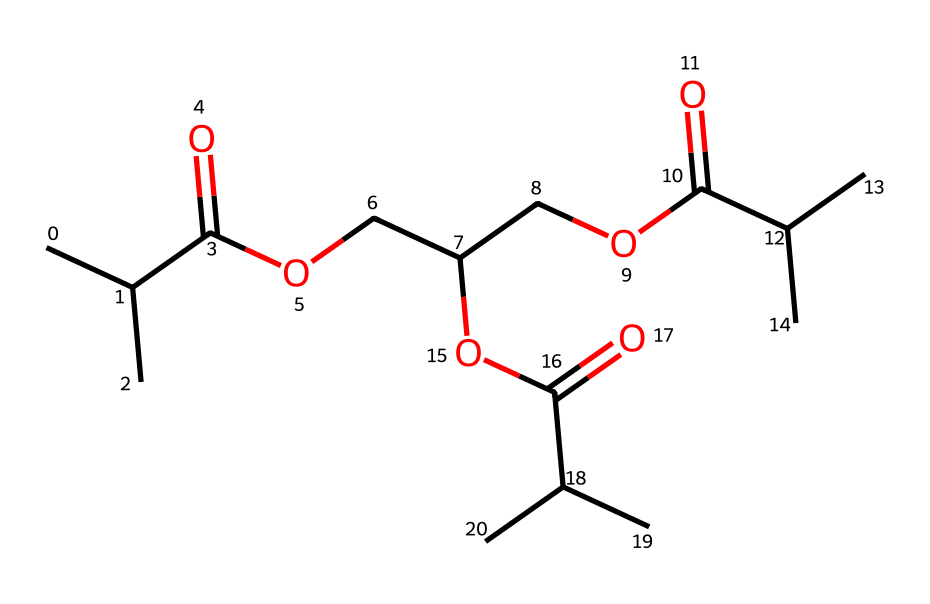What is the molecular formula of this chemical? To determine the molecular formula, we count the number of each type of atom present in the SMILES representation. Analyzing the structure, we identify 18 carbon atoms (C), 34 hydrogen atoms (H), and 6 oxygen atoms (O), leading us to the molecular formula of C18H34O6.
Answer: C18H34O6 How many ester functional groups are present? In the structure, we look for the ester functional group represented by the -COO- linkages. Each occurrence of -COO- demonstrates an ester bond. By inspecting the provided SMILES, we can identify three distinct areas where ester bonding occurs.
Answer: 3 What type of polymer does this structure represent? The presence of multiple ester groups, typically derived from polyesters, indicates that this chemical structure represents a type of polyester. Furthermore, the utilization and structure suggest it is a biodegradable polyester suitable for sustainable applications.
Answer: polyester How many carbon chains are branched in this polymer? By analyzing the SMILES representation, we can find that there are branches in the carbon chains. Each branching point leads multiple carbon atoms away from the primary chain, revealing that there are four branched carbon chains due to the linear sections connected to these branches.
Answer: 4 What is the main application of this polymer? Given the description of this polymer as a biodegradable polyester, its main application relates to sustainable packaging solutions that aim to reduce environmental impact through its degradability and eco-friendliness.
Answer: sustainable packaging 